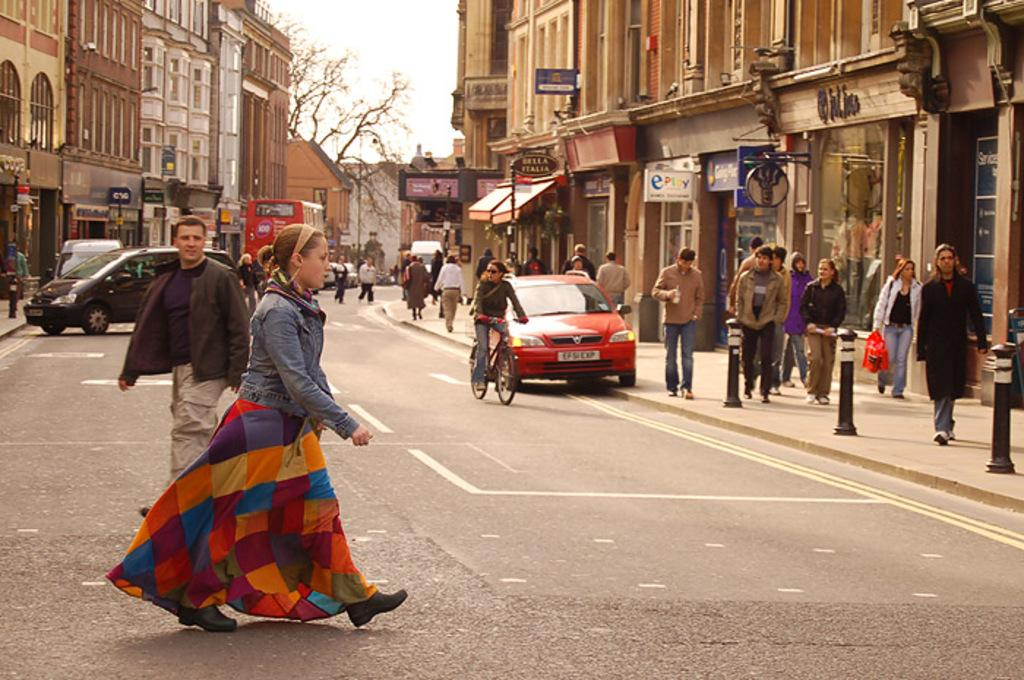What is the woman in the image doing? A woman is crossing the road in the image. What can be seen on the side of the road? There are people walking on the footpath. What type of vehicles are visible in the background? There are cars and a bus in the background. What degree is the woman holding in the image? There is no degree visible in the image; the woman is simply crossing the road. How many lizards can be seen on the footpath in the image? There are no lizards present in the image. 